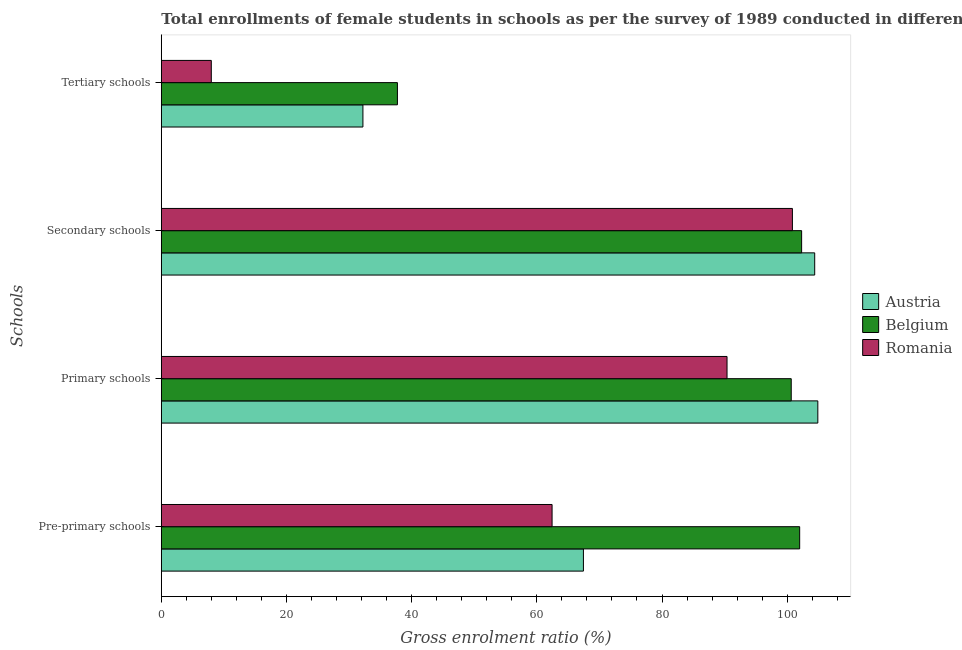How many different coloured bars are there?
Your answer should be compact. 3. How many bars are there on the 4th tick from the top?
Offer a terse response. 3. What is the label of the 2nd group of bars from the top?
Offer a very short reply. Secondary schools. What is the gross enrolment ratio(female) in tertiary schools in Belgium?
Keep it short and to the point. 37.73. Across all countries, what is the maximum gross enrolment ratio(female) in secondary schools?
Offer a terse response. 104.4. Across all countries, what is the minimum gross enrolment ratio(female) in secondary schools?
Keep it short and to the point. 100.83. In which country was the gross enrolment ratio(female) in tertiary schools minimum?
Ensure brevity in your answer.  Romania. What is the total gross enrolment ratio(female) in pre-primary schools in the graph?
Make the answer very short. 231.87. What is the difference between the gross enrolment ratio(female) in pre-primary schools in Austria and that in Romania?
Your response must be concise. 5.01. What is the difference between the gross enrolment ratio(female) in pre-primary schools in Belgium and the gross enrolment ratio(female) in secondary schools in Austria?
Provide a succinct answer. -2.4. What is the average gross enrolment ratio(female) in tertiary schools per country?
Offer a terse response. 25.97. What is the difference between the gross enrolment ratio(female) in secondary schools and gross enrolment ratio(female) in pre-primary schools in Austria?
Give a very brief answer. 36.95. In how many countries, is the gross enrolment ratio(female) in pre-primary schools greater than 24 %?
Ensure brevity in your answer.  3. What is the ratio of the gross enrolment ratio(female) in secondary schools in Belgium to that in Romania?
Your response must be concise. 1.01. Is the difference between the gross enrolment ratio(female) in primary schools in Belgium and Romania greater than the difference between the gross enrolment ratio(female) in tertiary schools in Belgium and Romania?
Offer a very short reply. No. What is the difference between the highest and the second highest gross enrolment ratio(female) in tertiary schools?
Ensure brevity in your answer.  5.51. What is the difference between the highest and the lowest gross enrolment ratio(female) in primary schools?
Your response must be concise. 14.51. In how many countries, is the gross enrolment ratio(female) in tertiary schools greater than the average gross enrolment ratio(female) in tertiary schools taken over all countries?
Provide a succinct answer. 2. What does the 1st bar from the bottom in Tertiary schools represents?
Offer a very short reply. Austria. Is it the case that in every country, the sum of the gross enrolment ratio(female) in pre-primary schools and gross enrolment ratio(female) in primary schools is greater than the gross enrolment ratio(female) in secondary schools?
Keep it short and to the point. Yes. Are all the bars in the graph horizontal?
Provide a succinct answer. Yes. How many countries are there in the graph?
Ensure brevity in your answer.  3. Are the values on the major ticks of X-axis written in scientific E-notation?
Provide a succinct answer. No. Does the graph contain grids?
Keep it short and to the point. No. What is the title of the graph?
Provide a short and direct response. Total enrollments of female students in schools as per the survey of 1989 conducted in different countries. Does "Turkmenistan" appear as one of the legend labels in the graph?
Your answer should be very brief. No. What is the label or title of the X-axis?
Make the answer very short. Gross enrolment ratio (%). What is the label or title of the Y-axis?
Offer a very short reply. Schools. What is the Gross enrolment ratio (%) of Austria in Pre-primary schools?
Offer a terse response. 67.44. What is the Gross enrolment ratio (%) in Belgium in Pre-primary schools?
Ensure brevity in your answer.  101.99. What is the Gross enrolment ratio (%) in Romania in Pre-primary schools?
Make the answer very short. 62.43. What is the Gross enrolment ratio (%) in Austria in Primary schools?
Provide a succinct answer. 104.9. What is the Gross enrolment ratio (%) in Belgium in Primary schools?
Make the answer very short. 100.65. What is the Gross enrolment ratio (%) in Romania in Primary schools?
Your answer should be very brief. 90.39. What is the Gross enrolment ratio (%) of Austria in Secondary schools?
Your response must be concise. 104.4. What is the Gross enrolment ratio (%) of Belgium in Secondary schools?
Provide a short and direct response. 102.31. What is the Gross enrolment ratio (%) of Romania in Secondary schools?
Your answer should be compact. 100.83. What is the Gross enrolment ratio (%) in Austria in Tertiary schools?
Ensure brevity in your answer.  32.21. What is the Gross enrolment ratio (%) of Belgium in Tertiary schools?
Keep it short and to the point. 37.73. What is the Gross enrolment ratio (%) in Romania in Tertiary schools?
Provide a succinct answer. 7.99. Across all Schools, what is the maximum Gross enrolment ratio (%) in Austria?
Give a very brief answer. 104.9. Across all Schools, what is the maximum Gross enrolment ratio (%) in Belgium?
Give a very brief answer. 102.31. Across all Schools, what is the maximum Gross enrolment ratio (%) of Romania?
Offer a terse response. 100.83. Across all Schools, what is the minimum Gross enrolment ratio (%) in Austria?
Ensure brevity in your answer.  32.21. Across all Schools, what is the minimum Gross enrolment ratio (%) in Belgium?
Your answer should be compact. 37.73. Across all Schools, what is the minimum Gross enrolment ratio (%) of Romania?
Keep it short and to the point. 7.99. What is the total Gross enrolment ratio (%) of Austria in the graph?
Your response must be concise. 308.95. What is the total Gross enrolment ratio (%) in Belgium in the graph?
Your response must be concise. 342.68. What is the total Gross enrolment ratio (%) in Romania in the graph?
Give a very brief answer. 261.64. What is the difference between the Gross enrolment ratio (%) in Austria in Pre-primary schools and that in Primary schools?
Your answer should be compact. -37.45. What is the difference between the Gross enrolment ratio (%) in Belgium in Pre-primary schools and that in Primary schools?
Your answer should be very brief. 1.35. What is the difference between the Gross enrolment ratio (%) of Romania in Pre-primary schools and that in Primary schools?
Give a very brief answer. -27.96. What is the difference between the Gross enrolment ratio (%) in Austria in Pre-primary schools and that in Secondary schools?
Provide a short and direct response. -36.95. What is the difference between the Gross enrolment ratio (%) in Belgium in Pre-primary schools and that in Secondary schools?
Give a very brief answer. -0.31. What is the difference between the Gross enrolment ratio (%) in Romania in Pre-primary schools and that in Secondary schools?
Your answer should be compact. -38.4. What is the difference between the Gross enrolment ratio (%) of Austria in Pre-primary schools and that in Tertiary schools?
Your answer should be compact. 35.23. What is the difference between the Gross enrolment ratio (%) in Belgium in Pre-primary schools and that in Tertiary schools?
Offer a terse response. 64.27. What is the difference between the Gross enrolment ratio (%) of Romania in Pre-primary schools and that in Tertiary schools?
Offer a very short reply. 54.45. What is the difference between the Gross enrolment ratio (%) in Austria in Primary schools and that in Secondary schools?
Your response must be concise. 0.5. What is the difference between the Gross enrolment ratio (%) of Belgium in Primary schools and that in Secondary schools?
Provide a short and direct response. -1.66. What is the difference between the Gross enrolment ratio (%) in Romania in Primary schools and that in Secondary schools?
Keep it short and to the point. -10.44. What is the difference between the Gross enrolment ratio (%) in Austria in Primary schools and that in Tertiary schools?
Ensure brevity in your answer.  72.68. What is the difference between the Gross enrolment ratio (%) in Belgium in Primary schools and that in Tertiary schools?
Your response must be concise. 62.92. What is the difference between the Gross enrolment ratio (%) in Romania in Primary schools and that in Tertiary schools?
Give a very brief answer. 82.4. What is the difference between the Gross enrolment ratio (%) of Austria in Secondary schools and that in Tertiary schools?
Make the answer very short. 72.19. What is the difference between the Gross enrolment ratio (%) of Belgium in Secondary schools and that in Tertiary schools?
Your answer should be very brief. 64.58. What is the difference between the Gross enrolment ratio (%) of Romania in Secondary schools and that in Tertiary schools?
Offer a very short reply. 92.85. What is the difference between the Gross enrolment ratio (%) in Austria in Pre-primary schools and the Gross enrolment ratio (%) in Belgium in Primary schools?
Your answer should be very brief. -33.2. What is the difference between the Gross enrolment ratio (%) in Austria in Pre-primary schools and the Gross enrolment ratio (%) in Romania in Primary schools?
Make the answer very short. -22.95. What is the difference between the Gross enrolment ratio (%) in Belgium in Pre-primary schools and the Gross enrolment ratio (%) in Romania in Primary schools?
Provide a succinct answer. 11.61. What is the difference between the Gross enrolment ratio (%) in Austria in Pre-primary schools and the Gross enrolment ratio (%) in Belgium in Secondary schools?
Provide a succinct answer. -34.86. What is the difference between the Gross enrolment ratio (%) in Austria in Pre-primary schools and the Gross enrolment ratio (%) in Romania in Secondary schools?
Offer a terse response. -33.39. What is the difference between the Gross enrolment ratio (%) in Belgium in Pre-primary schools and the Gross enrolment ratio (%) in Romania in Secondary schools?
Give a very brief answer. 1.16. What is the difference between the Gross enrolment ratio (%) in Austria in Pre-primary schools and the Gross enrolment ratio (%) in Belgium in Tertiary schools?
Give a very brief answer. 29.72. What is the difference between the Gross enrolment ratio (%) in Austria in Pre-primary schools and the Gross enrolment ratio (%) in Romania in Tertiary schools?
Your answer should be very brief. 59.46. What is the difference between the Gross enrolment ratio (%) of Belgium in Pre-primary schools and the Gross enrolment ratio (%) of Romania in Tertiary schools?
Offer a very short reply. 94.01. What is the difference between the Gross enrolment ratio (%) in Austria in Primary schools and the Gross enrolment ratio (%) in Belgium in Secondary schools?
Ensure brevity in your answer.  2.59. What is the difference between the Gross enrolment ratio (%) in Austria in Primary schools and the Gross enrolment ratio (%) in Romania in Secondary schools?
Give a very brief answer. 4.06. What is the difference between the Gross enrolment ratio (%) in Belgium in Primary schools and the Gross enrolment ratio (%) in Romania in Secondary schools?
Your response must be concise. -0.19. What is the difference between the Gross enrolment ratio (%) in Austria in Primary schools and the Gross enrolment ratio (%) in Belgium in Tertiary schools?
Give a very brief answer. 67.17. What is the difference between the Gross enrolment ratio (%) in Austria in Primary schools and the Gross enrolment ratio (%) in Romania in Tertiary schools?
Give a very brief answer. 96.91. What is the difference between the Gross enrolment ratio (%) in Belgium in Primary schools and the Gross enrolment ratio (%) in Romania in Tertiary schools?
Your answer should be compact. 92.66. What is the difference between the Gross enrolment ratio (%) in Austria in Secondary schools and the Gross enrolment ratio (%) in Belgium in Tertiary schools?
Your answer should be compact. 66.67. What is the difference between the Gross enrolment ratio (%) of Austria in Secondary schools and the Gross enrolment ratio (%) of Romania in Tertiary schools?
Ensure brevity in your answer.  96.41. What is the difference between the Gross enrolment ratio (%) of Belgium in Secondary schools and the Gross enrolment ratio (%) of Romania in Tertiary schools?
Your answer should be compact. 94.32. What is the average Gross enrolment ratio (%) in Austria per Schools?
Offer a terse response. 77.24. What is the average Gross enrolment ratio (%) of Belgium per Schools?
Offer a very short reply. 85.67. What is the average Gross enrolment ratio (%) in Romania per Schools?
Provide a short and direct response. 65.41. What is the difference between the Gross enrolment ratio (%) in Austria and Gross enrolment ratio (%) in Belgium in Pre-primary schools?
Give a very brief answer. -34.55. What is the difference between the Gross enrolment ratio (%) in Austria and Gross enrolment ratio (%) in Romania in Pre-primary schools?
Make the answer very short. 5.01. What is the difference between the Gross enrolment ratio (%) of Belgium and Gross enrolment ratio (%) of Romania in Pre-primary schools?
Offer a very short reply. 39.56. What is the difference between the Gross enrolment ratio (%) of Austria and Gross enrolment ratio (%) of Belgium in Primary schools?
Offer a very short reply. 4.25. What is the difference between the Gross enrolment ratio (%) of Austria and Gross enrolment ratio (%) of Romania in Primary schools?
Offer a very short reply. 14.51. What is the difference between the Gross enrolment ratio (%) in Belgium and Gross enrolment ratio (%) in Romania in Primary schools?
Offer a very short reply. 10.26. What is the difference between the Gross enrolment ratio (%) of Austria and Gross enrolment ratio (%) of Belgium in Secondary schools?
Your answer should be very brief. 2.09. What is the difference between the Gross enrolment ratio (%) in Austria and Gross enrolment ratio (%) in Romania in Secondary schools?
Offer a very short reply. 3.56. What is the difference between the Gross enrolment ratio (%) in Belgium and Gross enrolment ratio (%) in Romania in Secondary schools?
Make the answer very short. 1.47. What is the difference between the Gross enrolment ratio (%) of Austria and Gross enrolment ratio (%) of Belgium in Tertiary schools?
Ensure brevity in your answer.  -5.51. What is the difference between the Gross enrolment ratio (%) in Austria and Gross enrolment ratio (%) in Romania in Tertiary schools?
Ensure brevity in your answer.  24.23. What is the difference between the Gross enrolment ratio (%) in Belgium and Gross enrolment ratio (%) in Romania in Tertiary schools?
Your answer should be very brief. 29.74. What is the ratio of the Gross enrolment ratio (%) in Austria in Pre-primary schools to that in Primary schools?
Your answer should be very brief. 0.64. What is the ratio of the Gross enrolment ratio (%) of Belgium in Pre-primary schools to that in Primary schools?
Your answer should be compact. 1.01. What is the ratio of the Gross enrolment ratio (%) of Romania in Pre-primary schools to that in Primary schools?
Provide a short and direct response. 0.69. What is the ratio of the Gross enrolment ratio (%) in Austria in Pre-primary schools to that in Secondary schools?
Your response must be concise. 0.65. What is the ratio of the Gross enrolment ratio (%) in Romania in Pre-primary schools to that in Secondary schools?
Your response must be concise. 0.62. What is the ratio of the Gross enrolment ratio (%) of Austria in Pre-primary schools to that in Tertiary schools?
Provide a short and direct response. 2.09. What is the ratio of the Gross enrolment ratio (%) in Belgium in Pre-primary schools to that in Tertiary schools?
Provide a succinct answer. 2.7. What is the ratio of the Gross enrolment ratio (%) in Romania in Pre-primary schools to that in Tertiary schools?
Your answer should be very brief. 7.82. What is the ratio of the Gross enrolment ratio (%) of Belgium in Primary schools to that in Secondary schools?
Your response must be concise. 0.98. What is the ratio of the Gross enrolment ratio (%) of Romania in Primary schools to that in Secondary schools?
Make the answer very short. 0.9. What is the ratio of the Gross enrolment ratio (%) in Austria in Primary schools to that in Tertiary schools?
Keep it short and to the point. 3.26. What is the ratio of the Gross enrolment ratio (%) in Belgium in Primary schools to that in Tertiary schools?
Offer a terse response. 2.67. What is the ratio of the Gross enrolment ratio (%) of Romania in Primary schools to that in Tertiary schools?
Provide a short and direct response. 11.32. What is the ratio of the Gross enrolment ratio (%) in Austria in Secondary schools to that in Tertiary schools?
Keep it short and to the point. 3.24. What is the ratio of the Gross enrolment ratio (%) of Belgium in Secondary schools to that in Tertiary schools?
Ensure brevity in your answer.  2.71. What is the ratio of the Gross enrolment ratio (%) in Romania in Secondary schools to that in Tertiary schools?
Provide a succinct answer. 12.63. What is the difference between the highest and the second highest Gross enrolment ratio (%) of Austria?
Offer a very short reply. 0.5. What is the difference between the highest and the second highest Gross enrolment ratio (%) in Belgium?
Ensure brevity in your answer.  0.31. What is the difference between the highest and the second highest Gross enrolment ratio (%) in Romania?
Offer a terse response. 10.44. What is the difference between the highest and the lowest Gross enrolment ratio (%) of Austria?
Give a very brief answer. 72.68. What is the difference between the highest and the lowest Gross enrolment ratio (%) in Belgium?
Make the answer very short. 64.58. What is the difference between the highest and the lowest Gross enrolment ratio (%) of Romania?
Ensure brevity in your answer.  92.85. 